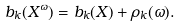<formula> <loc_0><loc_0><loc_500><loc_500>b _ { k } ( X ^ { \omega } ) = b _ { k } ( X ) + \rho _ { k } ( \omega ) .</formula> 